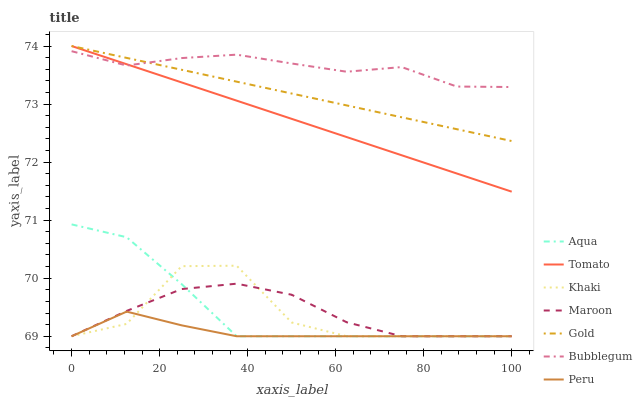Does Peru have the minimum area under the curve?
Answer yes or no. Yes. Does Bubblegum have the maximum area under the curve?
Answer yes or no. Yes. Does Khaki have the minimum area under the curve?
Answer yes or no. No. Does Khaki have the maximum area under the curve?
Answer yes or no. No. Is Gold the smoothest?
Answer yes or no. Yes. Is Khaki the roughest?
Answer yes or no. Yes. Is Khaki the smoothest?
Answer yes or no. No. Is Gold the roughest?
Answer yes or no. No. Does Gold have the lowest value?
Answer yes or no. No. Does Gold have the highest value?
Answer yes or no. Yes. Does Khaki have the highest value?
Answer yes or no. No. Is Maroon less than Bubblegum?
Answer yes or no. Yes. Is Tomato greater than Aqua?
Answer yes or no. Yes. Does Tomato intersect Bubblegum?
Answer yes or no. Yes. Is Tomato less than Bubblegum?
Answer yes or no. No. Is Tomato greater than Bubblegum?
Answer yes or no. No. Does Maroon intersect Bubblegum?
Answer yes or no. No. 